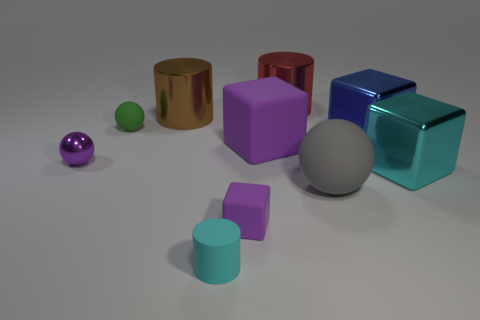Subtract all tiny blocks. How many blocks are left? 3 Subtract all gray spheres. How many spheres are left? 2 Subtract all cubes. How many objects are left? 6 Subtract 1 cubes. How many cubes are left? 3 Subtract all cyan cylinders. How many red spheres are left? 0 Subtract 1 purple blocks. How many objects are left? 9 Subtract all green cylinders. Subtract all green blocks. How many cylinders are left? 3 Subtract all tiny gray cylinders. Subtract all cyan matte cylinders. How many objects are left? 9 Add 8 big gray things. How many big gray things are left? 9 Add 6 brown matte objects. How many brown matte objects exist? 6 